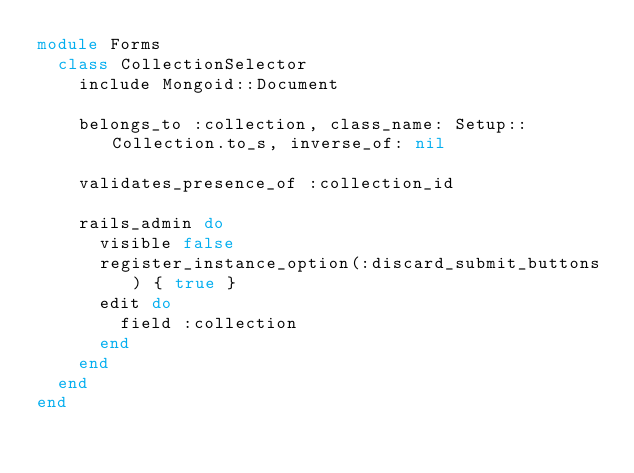<code> <loc_0><loc_0><loc_500><loc_500><_Ruby_>module Forms
  class CollectionSelector
    include Mongoid::Document

    belongs_to :collection, class_name: Setup::Collection.to_s, inverse_of: nil

    validates_presence_of :collection_id

    rails_admin do
      visible false
      register_instance_option(:discard_submit_buttons) { true }
      edit do
        field :collection
      end
    end
  end
end
</code> 